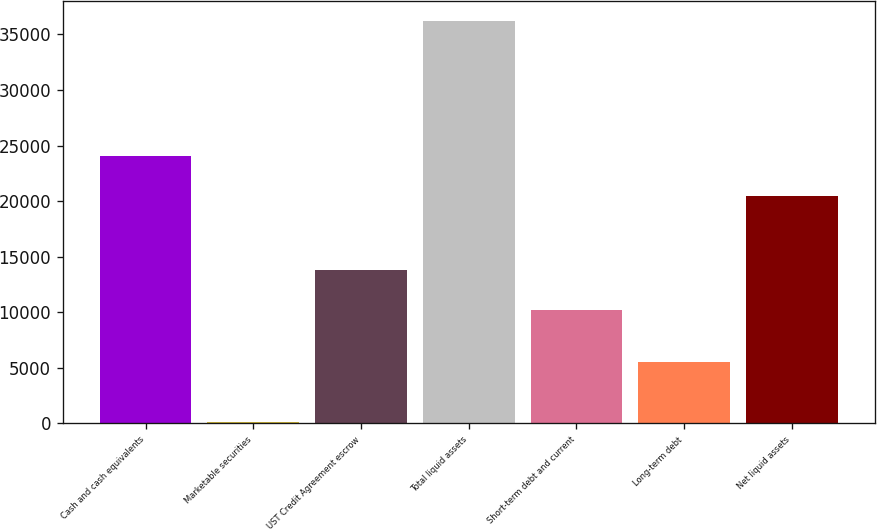Convert chart. <chart><loc_0><loc_0><loc_500><loc_500><bar_chart><fcel>Cash and cash equivalents<fcel>Marketable securities<fcel>UST Credit Agreement escrow<fcel>Total liquid assets<fcel>Short-term debt and current<fcel>Long-term debt<fcel>Net liquid assets<nl><fcel>24070.9<fcel>134<fcel>13831.9<fcel>36243<fcel>10221<fcel>5562<fcel>20460<nl></chart> 